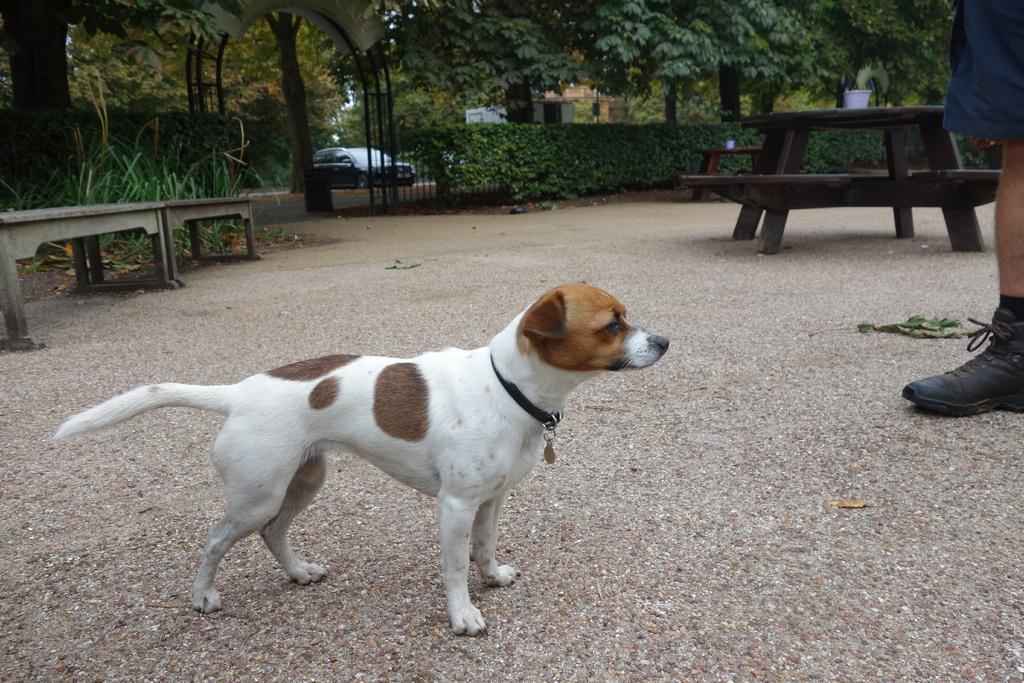In one or two sentences, can you explain what this image depicts? There is a white dog wearing belt is standing. There are benches, table, plants, trees, gate, railings , car in the background. On the right corner a person's leg and shoe is visible. 